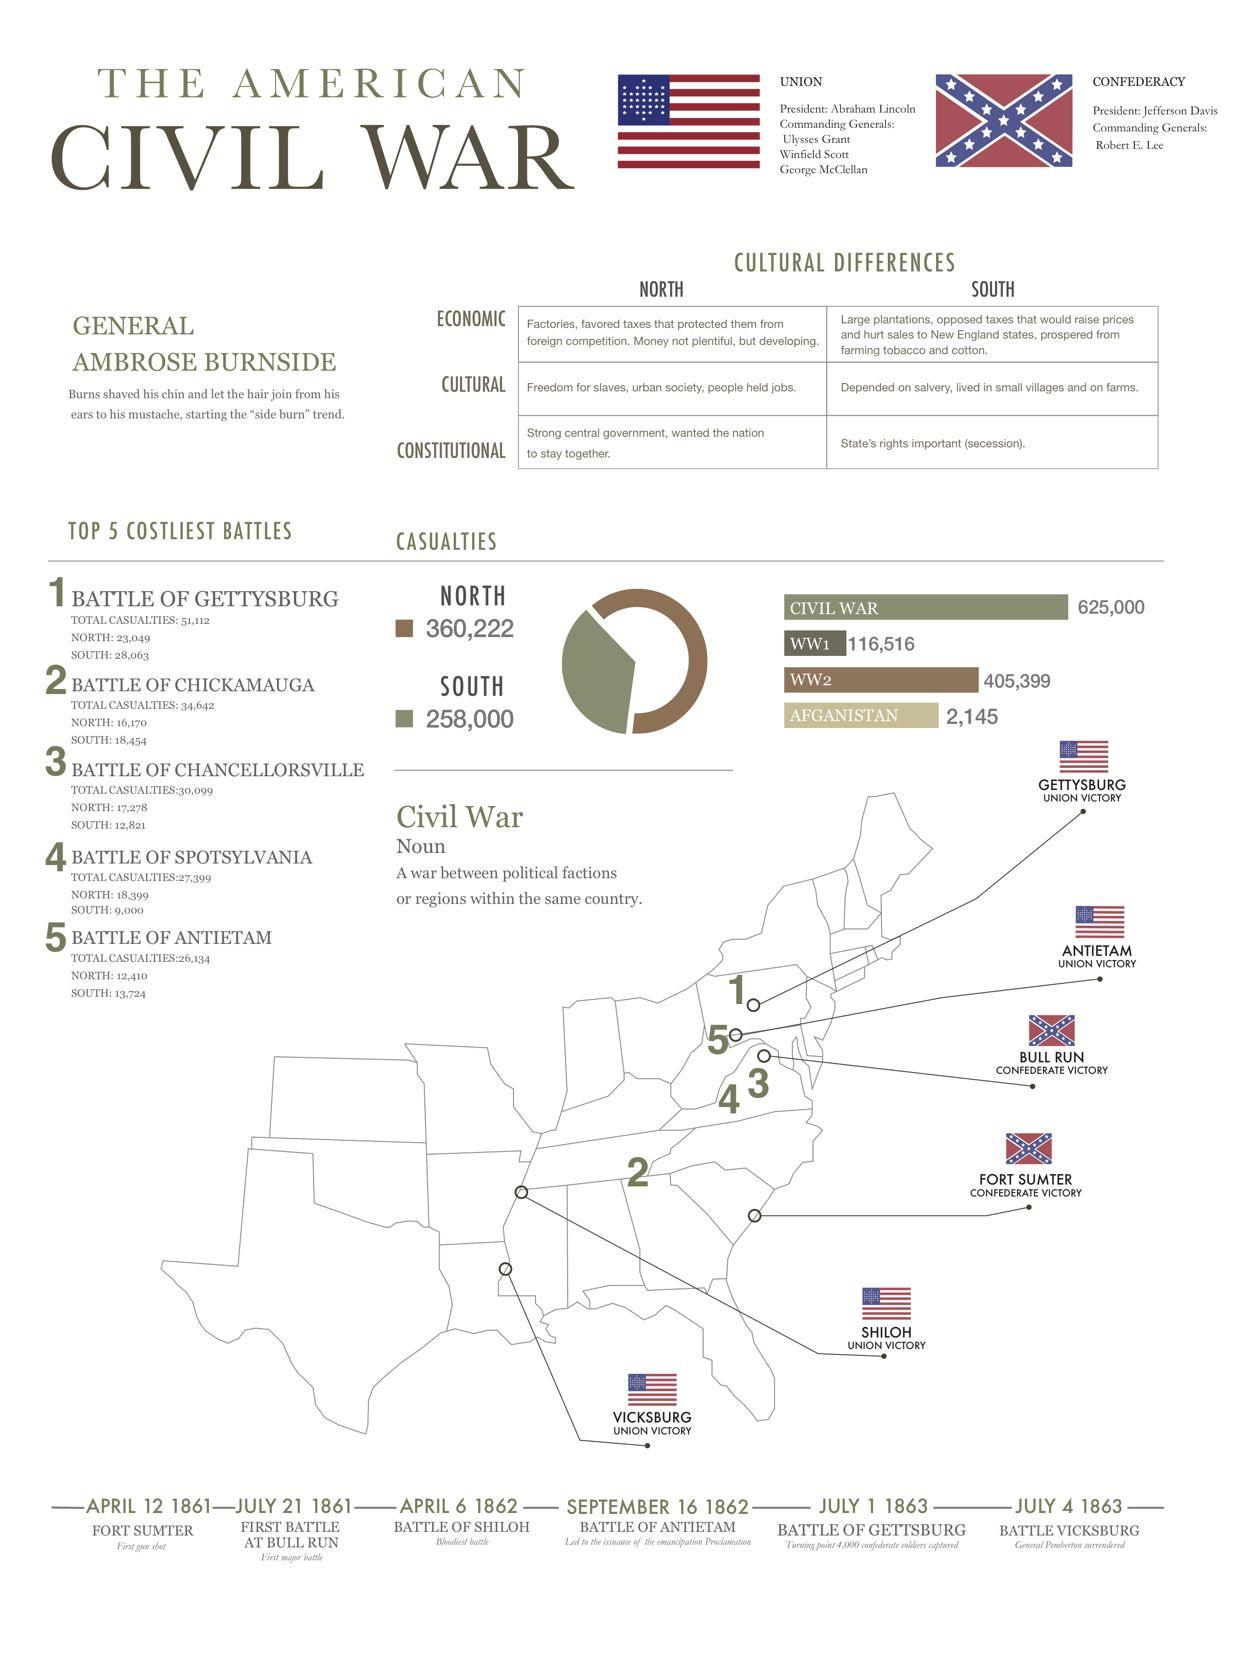Outline some significant characteristics in this image. The Battle of Antietam occurred earlier than the Battle of Vicksburg. The Battle of Chickamauga was the second most expensive battle in terms of lives lost and damage sustained. The battles that took place in 1863 were the Battle of Gettysburg and the Battle of Vicksburg. The infographic provides information on battles that occurred in 1862, including the Battle of Shiloh and the Battle of Antietam. The region with more casualties in the Battle of Chancellorsville was the North. 